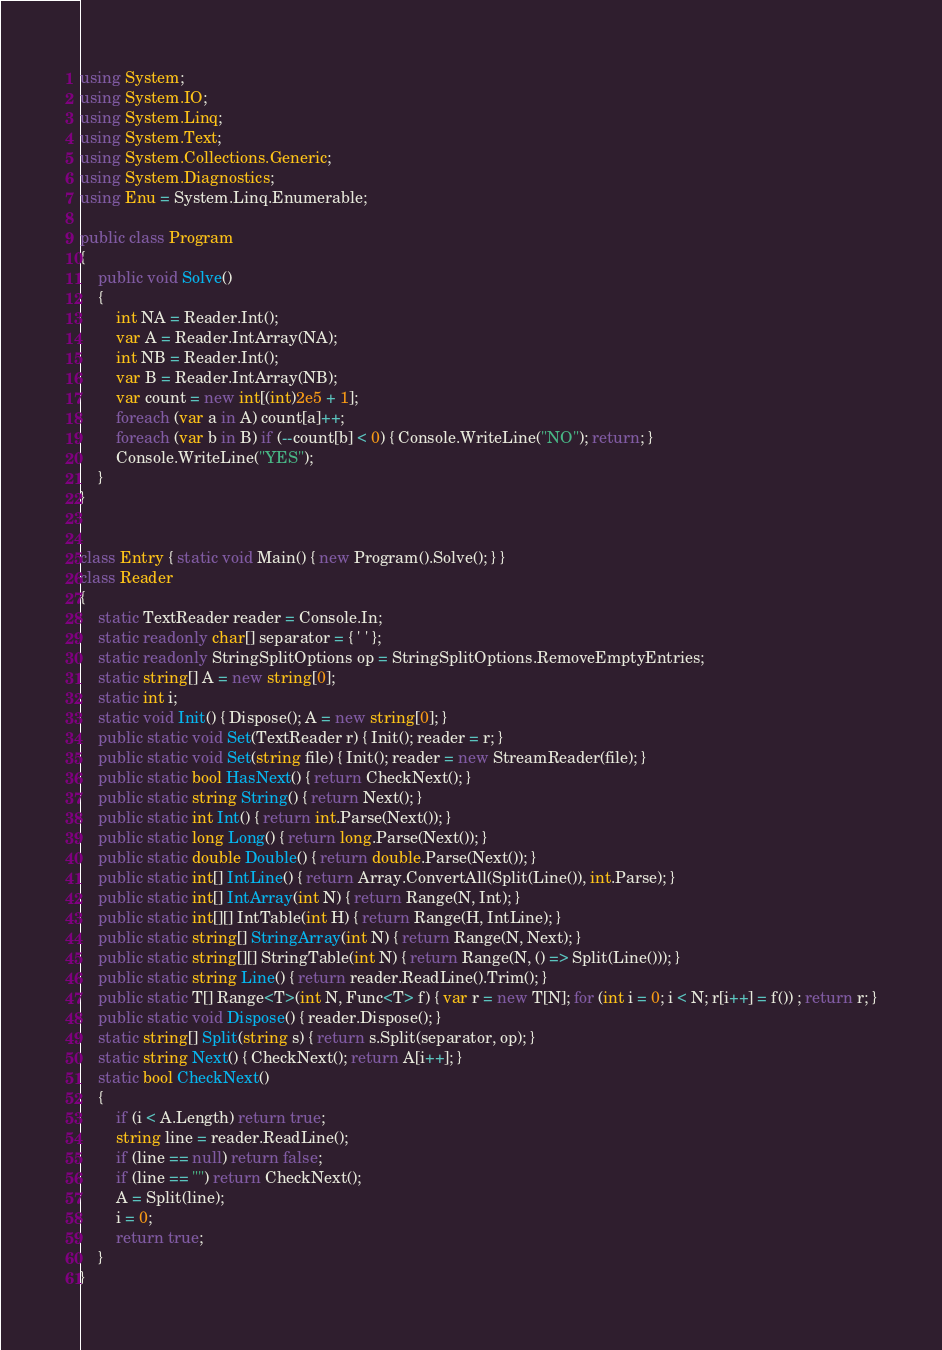Convert code to text. <code><loc_0><loc_0><loc_500><loc_500><_C#_>using System;
using System.IO;
using System.Linq;
using System.Text;
using System.Collections.Generic;
using System.Diagnostics;
using Enu = System.Linq.Enumerable;

public class Program
{
    public void Solve()
    {
        int NA = Reader.Int();
        var A = Reader.IntArray(NA);
        int NB = Reader.Int();
        var B = Reader.IntArray(NB);
        var count = new int[(int)2e5 + 1];
        foreach (var a in A) count[a]++;
        foreach (var b in B) if (--count[b] < 0) { Console.WriteLine("NO"); return; }
        Console.WriteLine("YES");
    }
}


class Entry { static void Main() { new Program().Solve(); } }
class Reader
{
    static TextReader reader = Console.In;
    static readonly char[] separator = { ' ' };
    static readonly StringSplitOptions op = StringSplitOptions.RemoveEmptyEntries;
    static string[] A = new string[0];
    static int i;
    static void Init() { Dispose(); A = new string[0]; }
    public static void Set(TextReader r) { Init(); reader = r; }
    public static void Set(string file) { Init(); reader = new StreamReader(file); }
    public static bool HasNext() { return CheckNext(); }
    public static string String() { return Next(); }
    public static int Int() { return int.Parse(Next()); }
    public static long Long() { return long.Parse(Next()); }
    public static double Double() { return double.Parse(Next()); }
    public static int[] IntLine() { return Array.ConvertAll(Split(Line()), int.Parse); }
    public static int[] IntArray(int N) { return Range(N, Int); }
    public static int[][] IntTable(int H) { return Range(H, IntLine); }
    public static string[] StringArray(int N) { return Range(N, Next); }
    public static string[][] StringTable(int N) { return Range(N, () => Split(Line())); }
    public static string Line() { return reader.ReadLine().Trim(); }
    public static T[] Range<T>(int N, Func<T> f) { var r = new T[N]; for (int i = 0; i < N; r[i++] = f()) ; return r; }
    public static void Dispose() { reader.Dispose(); }
    static string[] Split(string s) { return s.Split(separator, op); }
    static string Next() { CheckNext(); return A[i++]; }
    static bool CheckNext()
    {
        if (i < A.Length) return true;
        string line = reader.ReadLine();
        if (line == null) return false;
        if (line == "") return CheckNext();
        A = Split(line);
        i = 0;
        return true;
    }
}</code> 